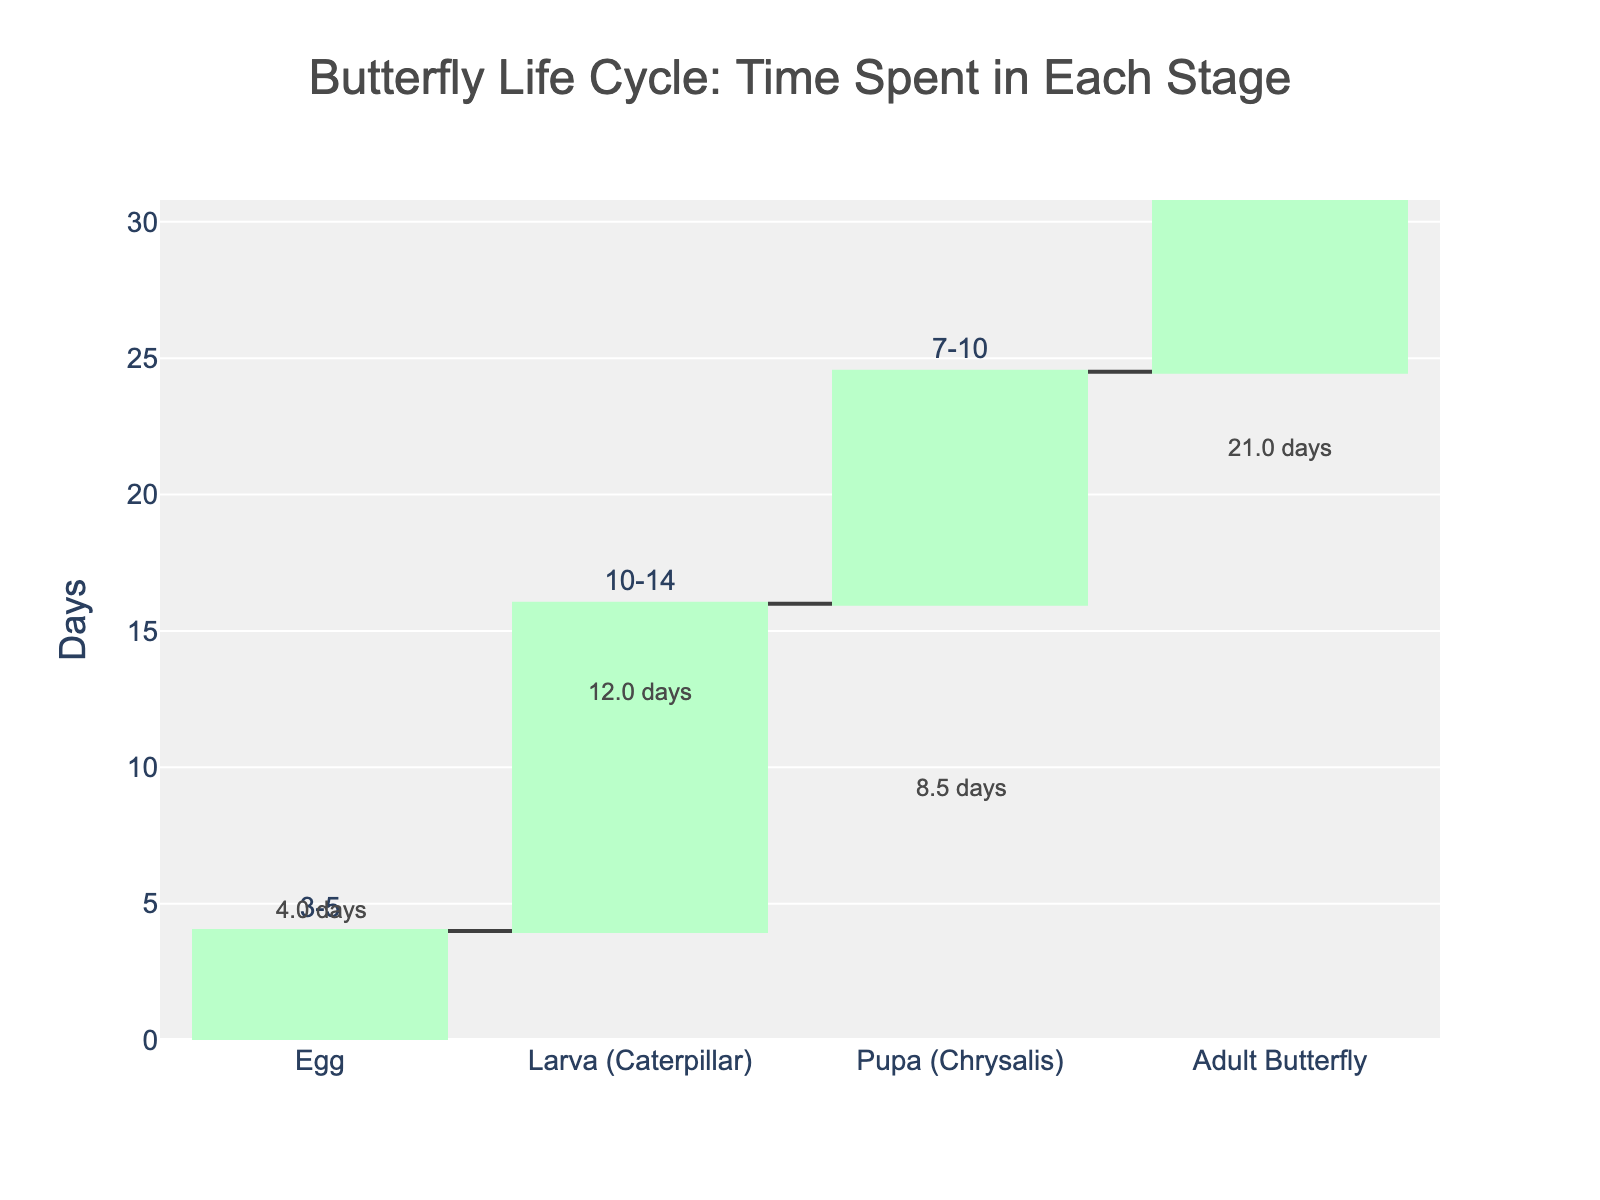What is the title of the chart? The title is displayed at the top center of the chart. The title is "Butterfly Life Cycle: Time Spent in Each Stage".
Answer: Butterfly Life Cycle: Time Spent in Each Stage Which stage of the butterfly's life cycle takes the longest time on average? The average duration of each stage is shown directly on the chart. The Adult Butterfly stage has the longest average time of 21 days.
Answer: Adult Butterfly How many stages are illustrated in the chart? The x-axis lists all stages of the butterfly's life cycle. There are four stages: Egg, Larva (Caterpillar), Pupa (Chrysalis), and Adult Butterfly.
Answer: Four What is the time range for the Pupa (Chrysalis) stage? For each stage, the time range is indicated. The Pupa (Chrysalis) stage ranges from 7 to 10 days.
Answer: 7-10 days Calculate the total average time spent in the Egg and Larva stages combined. The average time for Egg is (3+5)/2 = 4 days, and for Larva is (10+14)/2 = 12 days. Therefore, the combined average is 4 + 12 = 16 days.
Answer: 16 days Which stage comes immediately after the Larva (Caterpillar) stage in the butterfly's life cycle? The stages are ordered chronologically along the x-axis: Egg, Larva (Caterpillar), Pupa (Chrysalis), and Adult Butterfly. The stage following the Larva (Caterpillar) stage is Pupa (Chrysalis).
Answer: Pupa (Chrysalis) Compare the average time spent in the Pupa and Egg stages. Which one is longer? The average time for the Pupa stage is (7+10)/2 = 8.5 days, and for the Egg stage is (3+5)/2 = 4 days. Therefore, the Pupa stage is longer.
Answer: Pupa (Chrysalis) What is the total average time for the entire butterfly life cycle as shown in the chart? The total time is given in the dataset as 34-57 days. We can approximate by summing average times: Egg (4 days), Larva (12 days), Pupa (8.5 days), Adult (21 days). Thus, 4 + 12 + 8.5 + 21 = 45.5 days.
Answer: 45.5 days 